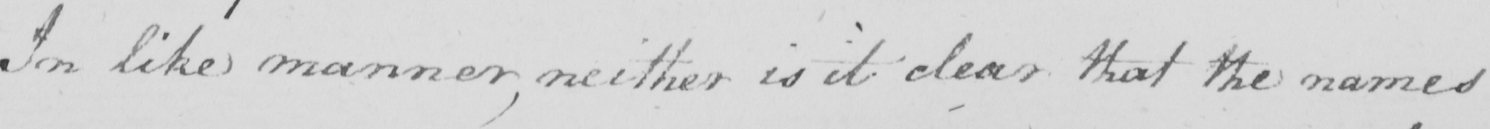What text is written in this handwritten line? In like manner , neither is it clear that the names 